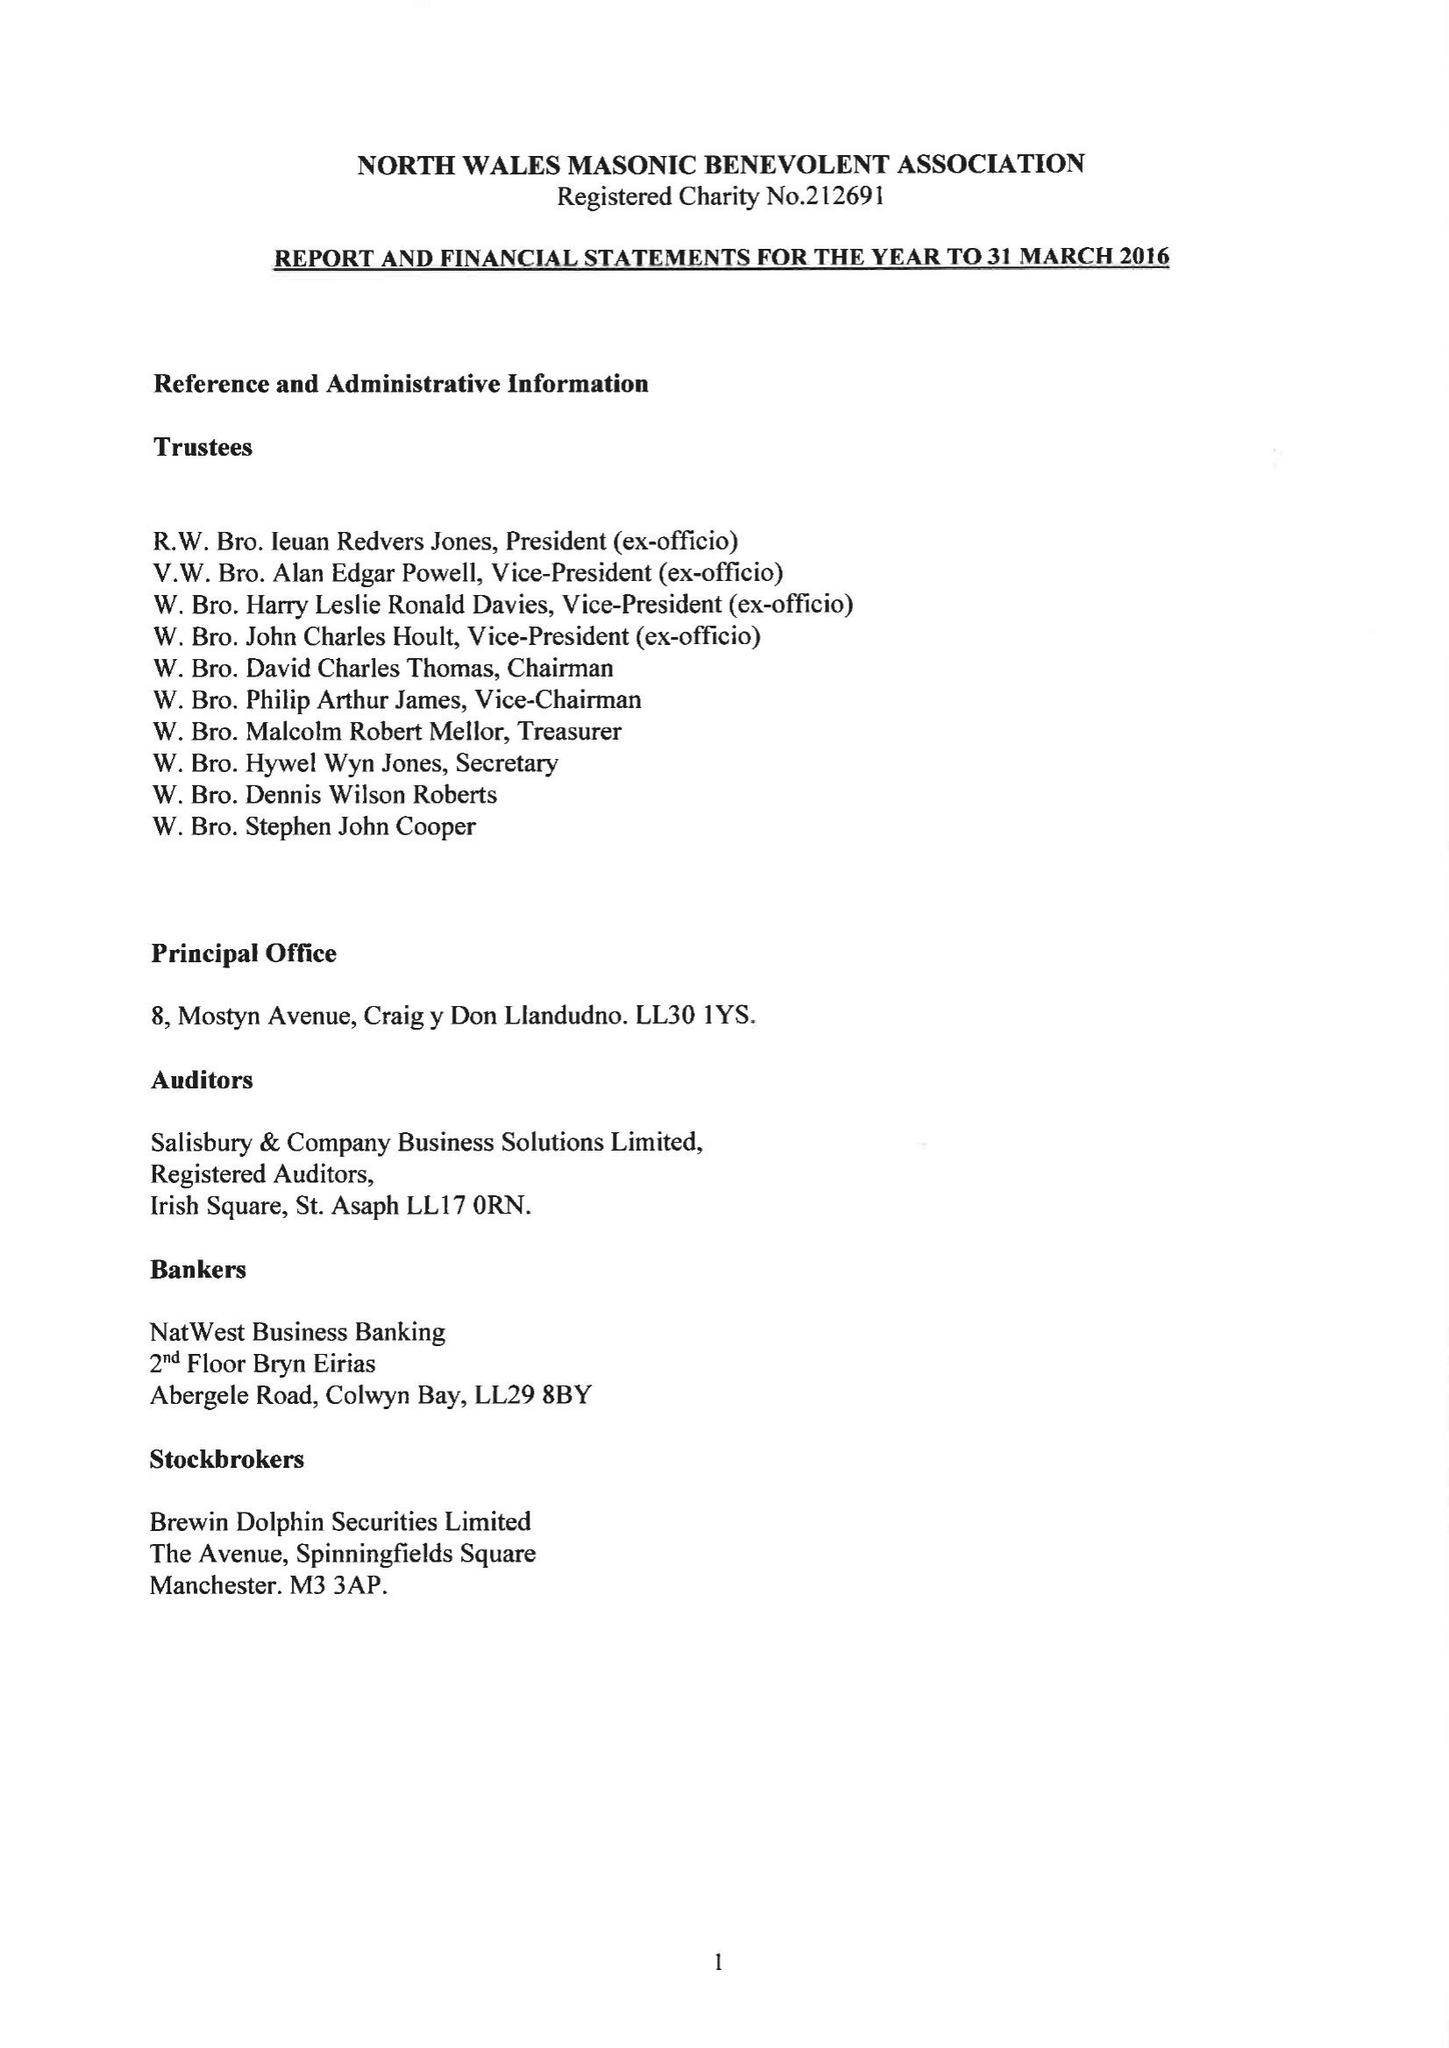What is the value for the spending_annually_in_british_pounds?
Answer the question using a single word or phrase. 379404.00 